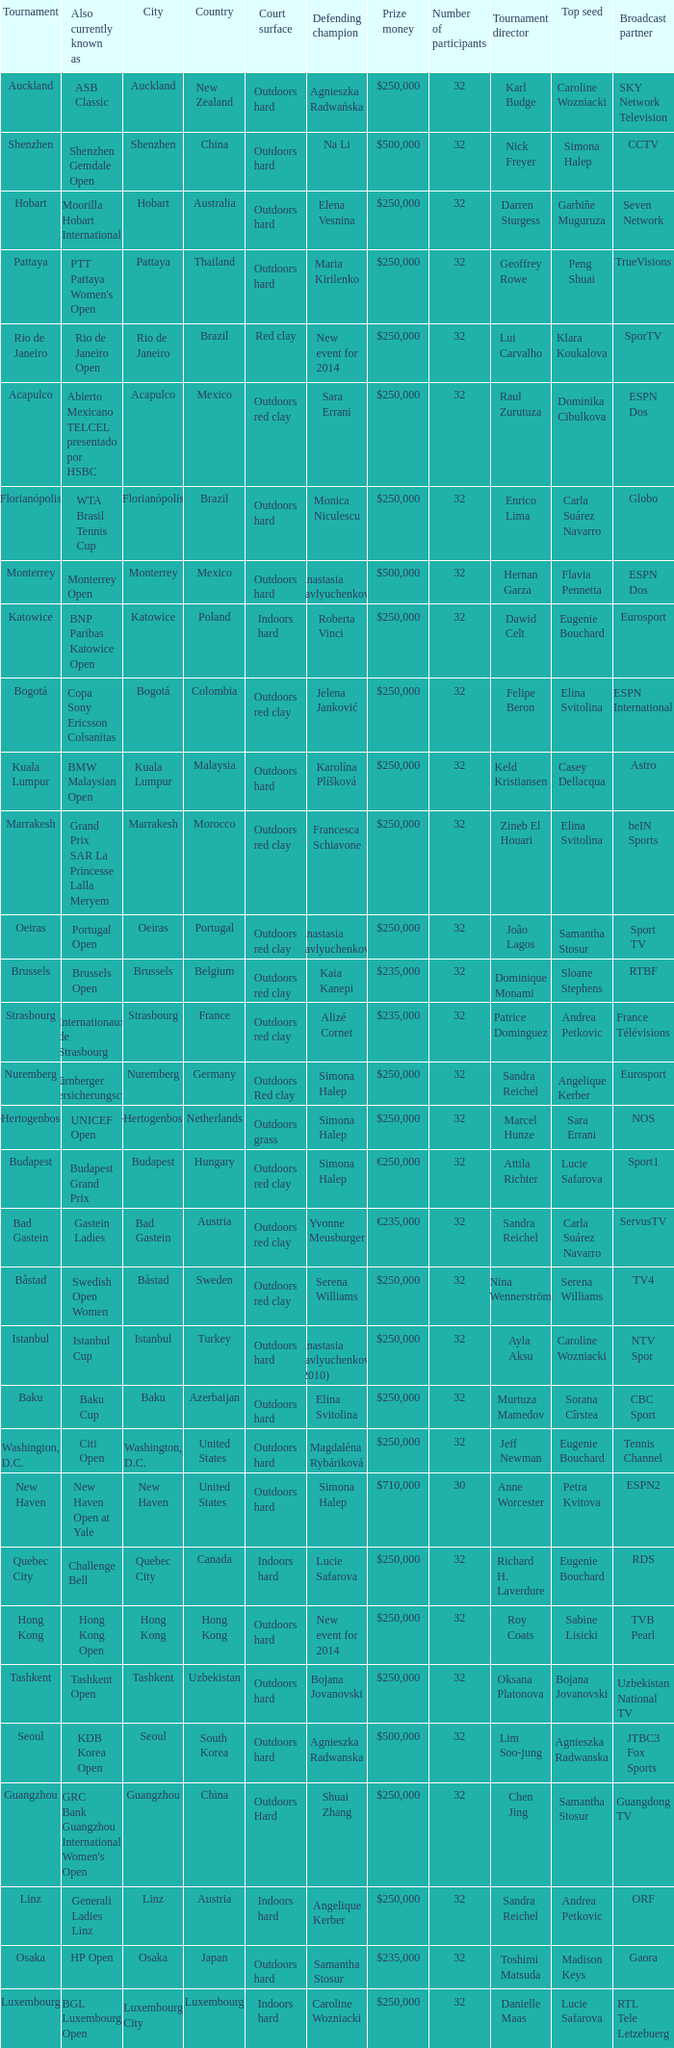How many defending champs from thailand? 1.0. 